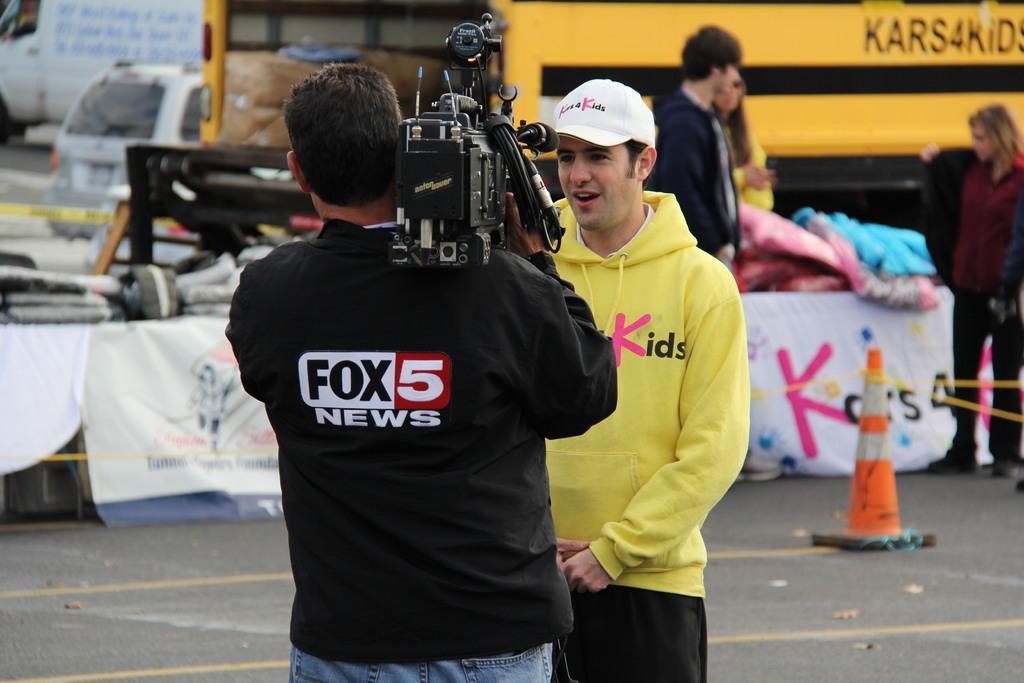Could you give a brief overview of what you see in this image? This picture shows a bus and a car and we see few clothes on the table and we see a man holding a camera and recording and we see another man standing in front of him. He wore a cap on his head and we see few people standing 